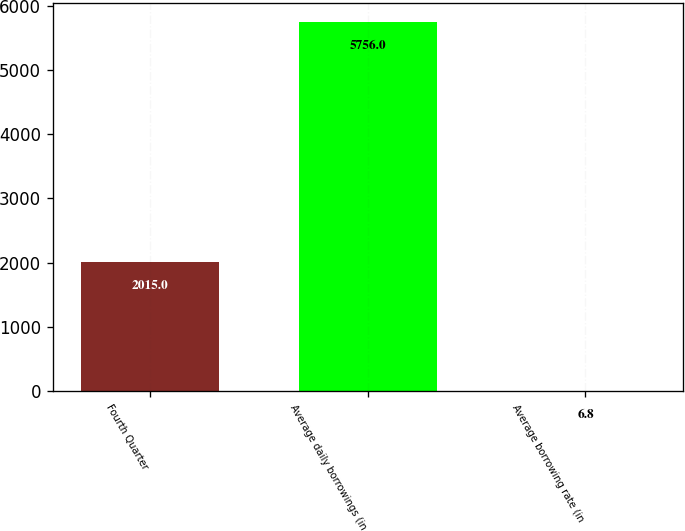Convert chart to OTSL. <chart><loc_0><loc_0><loc_500><loc_500><bar_chart><fcel>Fourth Quarter<fcel>Average daily borrowings (in<fcel>Average borrowing rate (in<nl><fcel>2015<fcel>5756<fcel>6.8<nl></chart> 